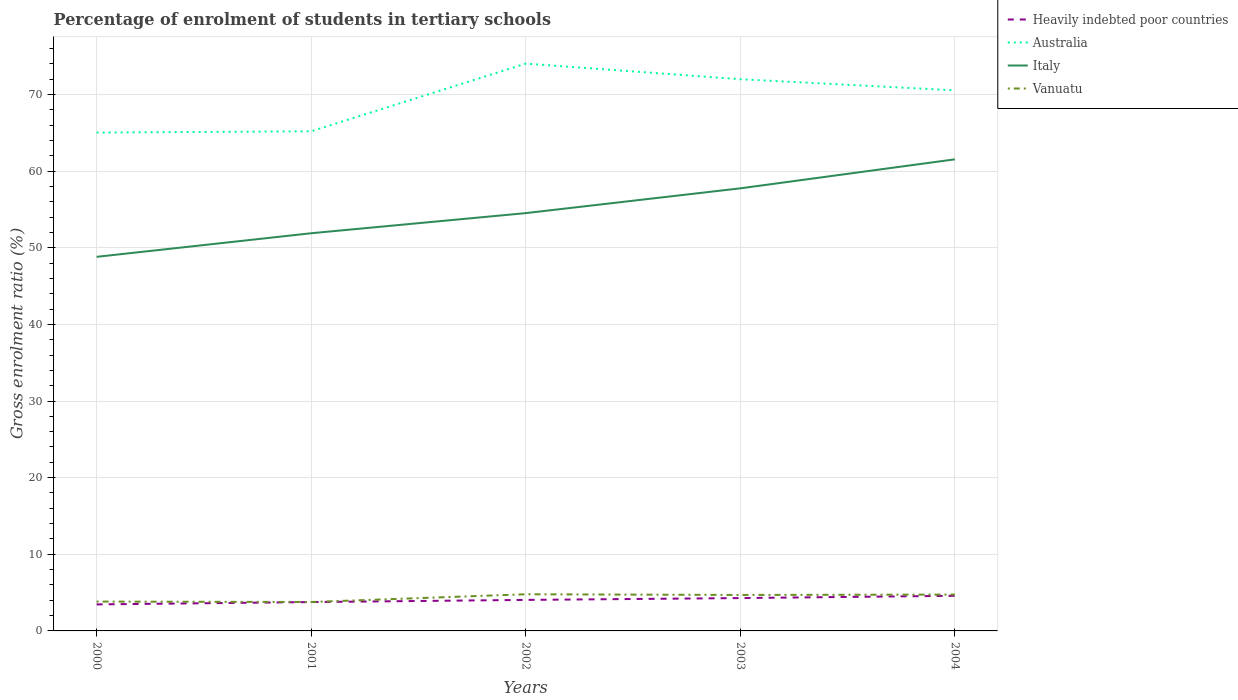Across all years, what is the maximum percentage of students enrolled in tertiary schools in Italy?
Your answer should be very brief. 48.81. In which year was the percentage of students enrolled in tertiary schools in Vanuatu maximum?
Your answer should be compact. 2001. What is the total percentage of students enrolled in tertiary schools in Italy in the graph?
Offer a terse response. -8.94. What is the difference between the highest and the second highest percentage of students enrolled in tertiary schools in Vanuatu?
Keep it short and to the point. 1.01. What is the difference between the highest and the lowest percentage of students enrolled in tertiary schools in Australia?
Ensure brevity in your answer.  3. How many lines are there?
Keep it short and to the point. 4. How many years are there in the graph?
Your answer should be compact. 5. What is the difference between two consecutive major ticks on the Y-axis?
Offer a very short reply. 10. Are the values on the major ticks of Y-axis written in scientific E-notation?
Offer a terse response. No. Does the graph contain any zero values?
Provide a short and direct response. No. How are the legend labels stacked?
Your answer should be very brief. Vertical. What is the title of the graph?
Your answer should be very brief. Percentage of enrolment of students in tertiary schools. What is the Gross enrolment ratio (%) in Heavily indebted poor countries in 2000?
Give a very brief answer. 3.46. What is the Gross enrolment ratio (%) in Australia in 2000?
Your answer should be compact. 65.03. What is the Gross enrolment ratio (%) of Italy in 2000?
Your answer should be very brief. 48.81. What is the Gross enrolment ratio (%) of Vanuatu in 2000?
Your response must be concise. 3.83. What is the Gross enrolment ratio (%) of Heavily indebted poor countries in 2001?
Your answer should be very brief. 3.76. What is the Gross enrolment ratio (%) of Australia in 2001?
Give a very brief answer. 65.19. What is the Gross enrolment ratio (%) of Italy in 2001?
Provide a short and direct response. 51.89. What is the Gross enrolment ratio (%) of Vanuatu in 2001?
Your answer should be very brief. 3.77. What is the Gross enrolment ratio (%) in Heavily indebted poor countries in 2002?
Make the answer very short. 4.05. What is the Gross enrolment ratio (%) in Australia in 2002?
Ensure brevity in your answer.  74.02. What is the Gross enrolment ratio (%) of Italy in 2002?
Offer a terse response. 54.52. What is the Gross enrolment ratio (%) of Vanuatu in 2002?
Give a very brief answer. 4.78. What is the Gross enrolment ratio (%) in Heavily indebted poor countries in 2003?
Offer a terse response. 4.29. What is the Gross enrolment ratio (%) in Australia in 2003?
Provide a succinct answer. 71.99. What is the Gross enrolment ratio (%) in Italy in 2003?
Your answer should be very brief. 57.75. What is the Gross enrolment ratio (%) of Vanuatu in 2003?
Your answer should be very brief. 4.69. What is the Gross enrolment ratio (%) of Heavily indebted poor countries in 2004?
Ensure brevity in your answer.  4.58. What is the Gross enrolment ratio (%) of Australia in 2004?
Give a very brief answer. 70.54. What is the Gross enrolment ratio (%) of Italy in 2004?
Your answer should be very brief. 61.53. What is the Gross enrolment ratio (%) in Vanuatu in 2004?
Ensure brevity in your answer.  4.74. Across all years, what is the maximum Gross enrolment ratio (%) in Heavily indebted poor countries?
Give a very brief answer. 4.58. Across all years, what is the maximum Gross enrolment ratio (%) in Australia?
Your answer should be compact. 74.02. Across all years, what is the maximum Gross enrolment ratio (%) of Italy?
Your response must be concise. 61.53. Across all years, what is the maximum Gross enrolment ratio (%) of Vanuatu?
Keep it short and to the point. 4.78. Across all years, what is the minimum Gross enrolment ratio (%) of Heavily indebted poor countries?
Make the answer very short. 3.46. Across all years, what is the minimum Gross enrolment ratio (%) in Australia?
Provide a short and direct response. 65.03. Across all years, what is the minimum Gross enrolment ratio (%) of Italy?
Your response must be concise. 48.81. Across all years, what is the minimum Gross enrolment ratio (%) in Vanuatu?
Your response must be concise. 3.77. What is the total Gross enrolment ratio (%) of Heavily indebted poor countries in the graph?
Your response must be concise. 20.14. What is the total Gross enrolment ratio (%) in Australia in the graph?
Offer a terse response. 346.76. What is the total Gross enrolment ratio (%) of Italy in the graph?
Provide a short and direct response. 274.5. What is the total Gross enrolment ratio (%) in Vanuatu in the graph?
Keep it short and to the point. 21.82. What is the difference between the Gross enrolment ratio (%) of Heavily indebted poor countries in 2000 and that in 2001?
Provide a short and direct response. -0.3. What is the difference between the Gross enrolment ratio (%) in Australia in 2000 and that in 2001?
Ensure brevity in your answer.  -0.17. What is the difference between the Gross enrolment ratio (%) of Italy in 2000 and that in 2001?
Ensure brevity in your answer.  -3.08. What is the difference between the Gross enrolment ratio (%) of Vanuatu in 2000 and that in 2001?
Provide a succinct answer. 0.06. What is the difference between the Gross enrolment ratio (%) of Heavily indebted poor countries in 2000 and that in 2002?
Provide a short and direct response. -0.59. What is the difference between the Gross enrolment ratio (%) in Australia in 2000 and that in 2002?
Your answer should be compact. -9. What is the difference between the Gross enrolment ratio (%) in Italy in 2000 and that in 2002?
Offer a very short reply. -5.7. What is the difference between the Gross enrolment ratio (%) of Vanuatu in 2000 and that in 2002?
Make the answer very short. -0.95. What is the difference between the Gross enrolment ratio (%) in Heavily indebted poor countries in 2000 and that in 2003?
Offer a very short reply. -0.83. What is the difference between the Gross enrolment ratio (%) of Australia in 2000 and that in 2003?
Make the answer very short. -6.96. What is the difference between the Gross enrolment ratio (%) in Italy in 2000 and that in 2003?
Your answer should be compact. -8.94. What is the difference between the Gross enrolment ratio (%) of Vanuatu in 2000 and that in 2003?
Your answer should be very brief. -0.86. What is the difference between the Gross enrolment ratio (%) in Heavily indebted poor countries in 2000 and that in 2004?
Give a very brief answer. -1.12. What is the difference between the Gross enrolment ratio (%) of Australia in 2000 and that in 2004?
Keep it short and to the point. -5.51. What is the difference between the Gross enrolment ratio (%) in Italy in 2000 and that in 2004?
Give a very brief answer. -12.72. What is the difference between the Gross enrolment ratio (%) in Vanuatu in 2000 and that in 2004?
Offer a very short reply. -0.91. What is the difference between the Gross enrolment ratio (%) in Heavily indebted poor countries in 2001 and that in 2002?
Ensure brevity in your answer.  -0.28. What is the difference between the Gross enrolment ratio (%) in Australia in 2001 and that in 2002?
Your answer should be very brief. -8.83. What is the difference between the Gross enrolment ratio (%) of Italy in 2001 and that in 2002?
Give a very brief answer. -2.63. What is the difference between the Gross enrolment ratio (%) of Vanuatu in 2001 and that in 2002?
Keep it short and to the point. -1.01. What is the difference between the Gross enrolment ratio (%) of Heavily indebted poor countries in 2001 and that in 2003?
Your answer should be compact. -0.52. What is the difference between the Gross enrolment ratio (%) of Australia in 2001 and that in 2003?
Your answer should be very brief. -6.8. What is the difference between the Gross enrolment ratio (%) of Italy in 2001 and that in 2003?
Offer a very short reply. -5.86. What is the difference between the Gross enrolment ratio (%) of Vanuatu in 2001 and that in 2003?
Keep it short and to the point. -0.92. What is the difference between the Gross enrolment ratio (%) in Heavily indebted poor countries in 2001 and that in 2004?
Keep it short and to the point. -0.82. What is the difference between the Gross enrolment ratio (%) of Australia in 2001 and that in 2004?
Ensure brevity in your answer.  -5.34. What is the difference between the Gross enrolment ratio (%) in Italy in 2001 and that in 2004?
Provide a succinct answer. -9.64. What is the difference between the Gross enrolment ratio (%) in Vanuatu in 2001 and that in 2004?
Offer a terse response. -0.97. What is the difference between the Gross enrolment ratio (%) in Heavily indebted poor countries in 2002 and that in 2003?
Provide a succinct answer. -0.24. What is the difference between the Gross enrolment ratio (%) in Australia in 2002 and that in 2003?
Ensure brevity in your answer.  2.04. What is the difference between the Gross enrolment ratio (%) of Italy in 2002 and that in 2003?
Make the answer very short. -3.23. What is the difference between the Gross enrolment ratio (%) of Vanuatu in 2002 and that in 2003?
Your answer should be compact. 0.09. What is the difference between the Gross enrolment ratio (%) of Heavily indebted poor countries in 2002 and that in 2004?
Your answer should be very brief. -0.54. What is the difference between the Gross enrolment ratio (%) in Australia in 2002 and that in 2004?
Your answer should be very brief. 3.49. What is the difference between the Gross enrolment ratio (%) in Italy in 2002 and that in 2004?
Offer a very short reply. -7.02. What is the difference between the Gross enrolment ratio (%) in Vanuatu in 2002 and that in 2004?
Your answer should be very brief. 0.04. What is the difference between the Gross enrolment ratio (%) of Heavily indebted poor countries in 2003 and that in 2004?
Your answer should be very brief. -0.3. What is the difference between the Gross enrolment ratio (%) of Australia in 2003 and that in 2004?
Ensure brevity in your answer.  1.45. What is the difference between the Gross enrolment ratio (%) of Italy in 2003 and that in 2004?
Keep it short and to the point. -3.78. What is the difference between the Gross enrolment ratio (%) of Vanuatu in 2003 and that in 2004?
Your answer should be very brief. -0.05. What is the difference between the Gross enrolment ratio (%) in Heavily indebted poor countries in 2000 and the Gross enrolment ratio (%) in Australia in 2001?
Offer a very short reply. -61.73. What is the difference between the Gross enrolment ratio (%) in Heavily indebted poor countries in 2000 and the Gross enrolment ratio (%) in Italy in 2001?
Your answer should be compact. -48.43. What is the difference between the Gross enrolment ratio (%) in Heavily indebted poor countries in 2000 and the Gross enrolment ratio (%) in Vanuatu in 2001?
Ensure brevity in your answer.  -0.31. What is the difference between the Gross enrolment ratio (%) of Australia in 2000 and the Gross enrolment ratio (%) of Italy in 2001?
Your answer should be very brief. 13.13. What is the difference between the Gross enrolment ratio (%) in Australia in 2000 and the Gross enrolment ratio (%) in Vanuatu in 2001?
Make the answer very short. 61.25. What is the difference between the Gross enrolment ratio (%) of Italy in 2000 and the Gross enrolment ratio (%) of Vanuatu in 2001?
Offer a terse response. 45.04. What is the difference between the Gross enrolment ratio (%) of Heavily indebted poor countries in 2000 and the Gross enrolment ratio (%) of Australia in 2002?
Make the answer very short. -70.56. What is the difference between the Gross enrolment ratio (%) in Heavily indebted poor countries in 2000 and the Gross enrolment ratio (%) in Italy in 2002?
Offer a very short reply. -51.06. What is the difference between the Gross enrolment ratio (%) of Heavily indebted poor countries in 2000 and the Gross enrolment ratio (%) of Vanuatu in 2002?
Provide a short and direct response. -1.32. What is the difference between the Gross enrolment ratio (%) in Australia in 2000 and the Gross enrolment ratio (%) in Italy in 2002?
Provide a short and direct response. 10.51. What is the difference between the Gross enrolment ratio (%) in Australia in 2000 and the Gross enrolment ratio (%) in Vanuatu in 2002?
Give a very brief answer. 60.24. What is the difference between the Gross enrolment ratio (%) in Italy in 2000 and the Gross enrolment ratio (%) in Vanuatu in 2002?
Give a very brief answer. 44.03. What is the difference between the Gross enrolment ratio (%) in Heavily indebted poor countries in 2000 and the Gross enrolment ratio (%) in Australia in 2003?
Keep it short and to the point. -68.53. What is the difference between the Gross enrolment ratio (%) in Heavily indebted poor countries in 2000 and the Gross enrolment ratio (%) in Italy in 2003?
Provide a short and direct response. -54.29. What is the difference between the Gross enrolment ratio (%) of Heavily indebted poor countries in 2000 and the Gross enrolment ratio (%) of Vanuatu in 2003?
Offer a very short reply. -1.23. What is the difference between the Gross enrolment ratio (%) in Australia in 2000 and the Gross enrolment ratio (%) in Italy in 2003?
Your response must be concise. 7.28. What is the difference between the Gross enrolment ratio (%) in Australia in 2000 and the Gross enrolment ratio (%) in Vanuatu in 2003?
Provide a short and direct response. 60.33. What is the difference between the Gross enrolment ratio (%) in Italy in 2000 and the Gross enrolment ratio (%) in Vanuatu in 2003?
Your answer should be very brief. 44.12. What is the difference between the Gross enrolment ratio (%) in Heavily indebted poor countries in 2000 and the Gross enrolment ratio (%) in Australia in 2004?
Your answer should be very brief. -67.08. What is the difference between the Gross enrolment ratio (%) in Heavily indebted poor countries in 2000 and the Gross enrolment ratio (%) in Italy in 2004?
Provide a short and direct response. -58.07. What is the difference between the Gross enrolment ratio (%) of Heavily indebted poor countries in 2000 and the Gross enrolment ratio (%) of Vanuatu in 2004?
Give a very brief answer. -1.28. What is the difference between the Gross enrolment ratio (%) in Australia in 2000 and the Gross enrolment ratio (%) in Italy in 2004?
Your response must be concise. 3.49. What is the difference between the Gross enrolment ratio (%) in Australia in 2000 and the Gross enrolment ratio (%) in Vanuatu in 2004?
Provide a succinct answer. 60.28. What is the difference between the Gross enrolment ratio (%) of Italy in 2000 and the Gross enrolment ratio (%) of Vanuatu in 2004?
Provide a short and direct response. 44.07. What is the difference between the Gross enrolment ratio (%) in Heavily indebted poor countries in 2001 and the Gross enrolment ratio (%) in Australia in 2002?
Keep it short and to the point. -70.26. What is the difference between the Gross enrolment ratio (%) of Heavily indebted poor countries in 2001 and the Gross enrolment ratio (%) of Italy in 2002?
Make the answer very short. -50.75. What is the difference between the Gross enrolment ratio (%) in Heavily indebted poor countries in 2001 and the Gross enrolment ratio (%) in Vanuatu in 2002?
Your answer should be compact. -1.02. What is the difference between the Gross enrolment ratio (%) in Australia in 2001 and the Gross enrolment ratio (%) in Italy in 2002?
Your response must be concise. 10.68. What is the difference between the Gross enrolment ratio (%) of Australia in 2001 and the Gross enrolment ratio (%) of Vanuatu in 2002?
Offer a terse response. 60.41. What is the difference between the Gross enrolment ratio (%) of Italy in 2001 and the Gross enrolment ratio (%) of Vanuatu in 2002?
Provide a short and direct response. 47.11. What is the difference between the Gross enrolment ratio (%) in Heavily indebted poor countries in 2001 and the Gross enrolment ratio (%) in Australia in 2003?
Your response must be concise. -68.22. What is the difference between the Gross enrolment ratio (%) of Heavily indebted poor countries in 2001 and the Gross enrolment ratio (%) of Italy in 2003?
Offer a very short reply. -53.99. What is the difference between the Gross enrolment ratio (%) of Heavily indebted poor countries in 2001 and the Gross enrolment ratio (%) of Vanuatu in 2003?
Make the answer very short. -0.93. What is the difference between the Gross enrolment ratio (%) in Australia in 2001 and the Gross enrolment ratio (%) in Italy in 2003?
Offer a terse response. 7.44. What is the difference between the Gross enrolment ratio (%) of Australia in 2001 and the Gross enrolment ratio (%) of Vanuatu in 2003?
Your answer should be compact. 60.5. What is the difference between the Gross enrolment ratio (%) of Italy in 2001 and the Gross enrolment ratio (%) of Vanuatu in 2003?
Make the answer very short. 47.2. What is the difference between the Gross enrolment ratio (%) of Heavily indebted poor countries in 2001 and the Gross enrolment ratio (%) of Australia in 2004?
Give a very brief answer. -66.77. What is the difference between the Gross enrolment ratio (%) of Heavily indebted poor countries in 2001 and the Gross enrolment ratio (%) of Italy in 2004?
Offer a terse response. -57.77. What is the difference between the Gross enrolment ratio (%) in Heavily indebted poor countries in 2001 and the Gross enrolment ratio (%) in Vanuatu in 2004?
Make the answer very short. -0.98. What is the difference between the Gross enrolment ratio (%) in Australia in 2001 and the Gross enrolment ratio (%) in Italy in 2004?
Make the answer very short. 3.66. What is the difference between the Gross enrolment ratio (%) in Australia in 2001 and the Gross enrolment ratio (%) in Vanuatu in 2004?
Your response must be concise. 60.45. What is the difference between the Gross enrolment ratio (%) in Italy in 2001 and the Gross enrolment ratio (%) in Vanuatu in 2004?
Your answer should be compact. 47.15. What is the difference between the Gross enrolment ratio (%) in Heavily indebted poor countries in 2002 and the Gross enrolment ratio (%) in Australia in 2003?
Your answer should be very brief. -67.94. What is the difference between the Gross enrolment ratio (%) in Heavily indebted poor countries in 2002 and the Gross enrolment ratio (%) in Italy in 2003?
Offer a very short reply. -53.7. What is the difference between the Gross enrolment ratio (%) of Heavily indebted poor countries in 2002 and the Gross enrolment ratio (%) of Vanuatu in 2003?
Ensure brevity in your answer.  -0.65. What is the difference between the Gross enrolment ratio (%) of Australia in 2002 and the Gross enrolment ratio (%) of Italy in 2003?
Provide a short and direct response. 16.27. What is the difference between the Gross enrolment ratio (%) in Australia in 2002 and the Gross enrolment ratio (%) in Vanuatu in 2003?
Ensure brevity in your answer.  69.33. What is the difference between the Gross enrolment ratio (%) in Italy in 2002 and the Gross enrolment ratio (%) in Vanuatu in 2003?
Provide a succinct answer. 49.83. What is the difference between the Gross enrolment ratio (%) in Heavily indebted poor countries in 2002 and the Gross enrolment ratio (%) in Australia in 2004?
Your answer should be very brief. -66.49. What is the difference between the Gross enrolment ratio (%) in Heavily indebted poor countries in 2002 and the Gross enrolment ratio (%) in Italy in 2004?
Make the answer very short. -57.49. What is the difference between the Gross enrolment ratio (%) in Heavily indebted poor countries in 2002 and the Gross enrolment ratio (%) in Vanuatu in 2004?
Offer a terse response. -0.7. What is the difference between the Gross enrolment ratio (%) of Australia in 2002 and the Gross enrolment ratio (%) of Italy in 2004?
Keep it short and to the point. 12.49. What is the difference between the Gross enrolment ratio (%) in Australia in 2002 and the Gross enrolment ratio (%) in Vanuatu in 2004?
Ensure brevity in your answer.  69.28. What is the difference between the Gross enrolment ratio (%) in Italy in 2002 and the Gross enrolment ratio (%) in Vanuatu in 2004?
Provide a succinct answer. 49.77. What is the difference between the Gross enrolment ratio (%) of Heavily indebted poor countries in 2003 and the Gross enrolment ratio (%) of Australia in 2004?
Make the answer very short. -66.25. What is the difference between the Gross enrolment ratio (%) in Heavily indebted poor countries in 2003 and the Gross enrolment ratio (%) in Italy in 2004?
Your answer should be compact. -57.25. What is the difference between the Gross enrolment ratio (%) of Heavily indebted poor countries in 2003 and the Gross enrolment ratio (%) of Vanuatu in 2004?
Provide a short and direct response. -0.46. What is the difference between the Gross enrolment ratio (%) of Australia in 2003 and the Gross enrolment ratio (%) of Italy in 2004?
Ensure brevity in your answer.  10.45. What is the difference between the Gross enrolment ratio (%) of Australia in 2003 and the Gross enrolment ratio (%) of Vanuatu in 2004?
Offer a very short reply. 67.24. What is the difference between the Gross enrolment ratio (%) of Italy in 2003 and the Gross enrolment ratio (%) of Vanuatu in 2004?
Give a very brief answer. 53.01. What is the average Gross enrolment ratio (%) in Heavily indebted poor countries per year?
Offer a terse response. 4.03. What is the average Gross enrolment ratio (%) in Australia per year?
Your response must be concise. 69.35. What is the average Gross enrolment ratio (%) in Italy per year?
Give a very brief answer. 54.9. What is the average Gross enrolment ratio (%) in Vanuatu per year?
Offer a very short reply. 4.36. In the year 2000, what is the difference between the Gross enrolment ratio (%) of Heavily indebted poor countries and Gross enrolment ratio (%) of Australia?
Offer a terse response. -61.57. In the year 2000, what is the difference between the Gross enrolment ratio (%) of Heavily indebted poor countries and Gross enrolment ratio (%) of Italy?
Ensure brevity in your answer.  -45.35. In the year 2000, what is the difference between the Gross enrolment ratio (%) of Heavily indebted poor countries and Gross enrolment ratio (%) of Vanuatu?
Give a very brief answer. -0.37. In the year 2000, what is the difference between the Gross enrolment ratio (%) of Australia and Gross enrolment ratio (%) of Italy?
Offer a very short reply. 16.21. In the year 2000, what is the difference between the Gross enrolment ratio (%) of Australia and Gross enrolment ratio (%) of Vanuatu?
Your answer should be compact. 61.2. In the year 2000, what is the difference between the Gross enrolment ratio (%) in Italy and Gross enrolment ratio (%) in Vanuatu?
Provide a succinct answer. 44.98. In the year 2001, what is the difference between the Gross enrolment ratio (%) in Heavily indebted poor countries and Gross enrolment ratio (%) in Australia?
Offer a terse response. -61.43. In the year 2001, what is the difference between the Gross enrolment ratio (%) in Heavily indebted poor countries and Gross enrolment ratio (%) in Italy?
Your response must be concise. -48.13. In the year 2001, what is the difference between the Gross enrolment ratio (%) of Heavily indebted poor countries and Gross enrolment ratio (%) of Vanuatu?
Keep it short and to the point. -0.01. In the year 2001, what is the difference between the Gross enrolment ratio (%) in Australia and Gross enrolment ratio (%) in Italy?
Ensure brevity in your answer.  13.3. In the year 2001, what is the difference between the Gross enrolment ratio (%) in Australia and Gross enrolment ratio (%) in Vanuatu?
Your answer should be compact. 61.42. In the year 2001, what is the difference between the Gross enrolment ratio (%) of Italy and Gross enrolment ratio (%) of Vanuatu?
Offer a terse response. 48.12. In the year 2002, what is the difference between the Gross enrolment ratio (%) of Heavily indebted poor countries and Gross enrolment ratio (%) of Australia?
Your answer should be very brief. -69.98. In the year 2002, what is the difference between the Gross enrolment ratio (%) of Heavily indebted poor countries and Gross enrolment ratio (%) of Italy?
Your answer should be very brief. -50.47. In the year 2002, what is the difference between the Gross enrolment ratio (%) of Heavily indebted poor countries and Gross enrolment ratio (%) of Vanuatu?
Ensure brevity in your answer.  -0.74. In the year 2002, what is the difference between the Gross enrolment ratio (%) of Australia and Gross enrolment ratio (%) of Italy?
Ensure brevity in your answer.  19.51. In the year 2002, what is the difference between the Gross enrolment ratio (%) in Australia and Gross enrolment ratio (%) in Vanuatu?
Provide a short and direct response. 69.24. In the year 2002, what is the difference between the Gross enrolment ratio (%) of Italy and Gross enrolment ratio (%) of Vanuatu?
Offer a terse response. 49.73. In the year 2003, what is the difference between the Gross enrolment ratio (%) of Heavily indebted poor countries and Gross enrolment ratio (%) of Australia?
Your response must be concise. -67.7. In the year 2003, what is the difference between the Gross enrolment ratio (%) of Heavily indebted poor countries and Gross enrolment ratio (%) of Italy?
Give a very brief answer. -53.46. In the year 2003, what is the difference between the Gross enrolment ratio (%) in Heavily indebted poor countries and Gross enrolment ratio (%) in Vanuatu?
Your response must be concise. -0.41. In the year 2003, what is the difference between the Gross enrolment ratio (%) in Australia and Gross enrolment ratio (%) in Italy?
Offer a terse response. 14.24. In the year 2003, what is the difference between the Gross enrolment ratio (%) in Australia and Gross enrolment ratio (%) in Vanuatu?
Provide a succinct answer. 67.3. In the year 2003, what is the difference between the Gross enrolment ratio (%) in Italy and Gross enrolment ratio (%) in Vanuatu?
Offer a terse response. 53.06. In the year 2004, what is the difference between the Gross enrolment ratio (%) of Heavily indebted poor countries and Gross enrolment ratio (%) of Australia?
Provide a succinct answer. -65.95. In the year 2004, what is the difference between the Gross enrolment ratio (%) of Heavily indebted poor countries and Gross enrolment ratio (%) of Italy?
Keep it short and to the point. -56.95. In the year 2004, what is the difference between the Gross enrolment ratio (%) in Heavily indebted poor countries and Gross enrolment ratio (%) in Vanuatu?
Your answer should be very brief. -0.16. In the year 2004, what is the difference between the Gross enrolment ratio (%) of Australia and Gross enrolment ratio (%) of Italy?
Make the answer very short. 9. In the year 2004, what is the difference between the Gross enrolment ratio (%) of Australia and Gross enrolment ratio (%) of Vanuatu?
Offer a very short reply. 65.79. In the year 2004, what is the difference between the Gross enrolment ratio (%) of Italy and Gross enrolment ratio (%) of Vanuatu?
Keep it short and to the point. 56.79. What is the ratio of the Gross enrolment ratio (%) in Heavily indebted poor countries in 2000 to that in 2001?
Provide a short and direct response. 0.92. What is the ratio of the Gross enrolment ratio (%) in Italy in 2000 to that in 2001?
Keep it short and to the point. 0.94. What is the ratio of the Gross enrolment ratio (%) in Vanuatu in 2000 to that in 2001?
Keep it short and to the point. 1.01. What is the ratio of the Gross enrolment ratio (%) of Heavily indebted poor countries in 2000 to that in 2002?
Your answer should be compact. 0.86. What is the ratio of the Gross enrolment ratio (%) in Australia in 2000 to that in 2002?
Your answer should be very brief. 0.88. What is the ratio of the Gross enrolment ratio (%) of Italy in 2000 to that in 2002?
Your answer should be compact. 0.9. What is the ratio of the Gross enrolment ratio (%) of Vanuatu in 2000 to that in 2002?
Your answer should be compact. 0.8. What is the ratio of the Gross enrolment ratio (%) of Heavily indebted poor countries in 2000 to that in 2003?
Offer a terse response. 0.81. What is the ratio of the Gross enrolment ratio (%) of Australia in 2000 to that in 2003?
Give a very brief answer. 0.9. What is the ratio of the Gross enrolment ratio (%) of Italy in 2000 to that in 2003?
Your answer should be very brief. 0.85. What is the ratio of the Gross enrolment ratio (%) in Vanuatu in 2000 to that in 2003?
Provide a succinct answer. 0.82. What is the ratio of the Gross enrolment ratio (%) of Heavily indebted poor countries in 2000 to that in 2004?
Give a very brief answer. 0.75. What is the ratio of the Gross enrolment ratio (%) of Australia in 2000 to that in 2004?
Give a very brief answer. 0.92. What is the ratio of the Gross enrolment ratio (%) of Italy in 2000 to that in 2004?
Keep it short and to the point. 0.79. What is the ratio of the Gross enrolment ratio (%) in Vanuatu in 2000 to that in 2004?
Make the answer very short. 0.81. What is the ratio of the Gross enrolment ratio (%) of Heavily indebted poor countries in 2001 to that in 2002?
Your answer should be compact. 0.93. What is the ratio of the Gross enrolment ratio (%) of Australia in 2001 to that in 2002?
Keep it short and to the point. 0.88. What is the ratio of the Gross enrolment ratio (%) of Italy in 2001 to that in 2002?
Make the answer very short. 0.95. What is the ratio of the Gross enrolment ratio (%) in Vanuatu in 2001 to that in 2002?
Provide a succinct answer. 0.79. What is the ratio of the Gross enrolment ratio (%) in Heavily indebted poor countries in 2001 to that in 2003?
Ensure brevity in your answer.  0.88. What is the ratio of the Gross enrolment ratio (%) in Australia in 2001 to that in 2003?
Give a very brief answer. 0.91. What is the ratio of the Gross enrolment ratio (%) in Italy in 2001 to that in 2003?
Ensure brevity in your answer.  0.9. What is the ratio of the Gross enrolment ratio (%) in Vanuatu in 2001 to that in 2003?
Offer a very short reply. 0.8. What is the ratio of the Gross enrolment ratio (%) of Heavily indebted poor countries in 2001 to that in 2004?
Keep it short and to the point. 0.82. What is the ratio of the Gross enrolment ratio (%) of Australia in 2001 to that in 2004?
Your response must be concise. 0.92. What is the ratio of the Gross enrolment ratio (%) in Italy in 2001 to that in 2004?
Keep it short and to the point. 0.84. What is the ratio of the Gross enrolment ratio (%) in Vanuatu in 2001 to that in 2004?
Provide a short and direct response. 0.8. What is the ratio of the Gross enrolment ratio (%) in Heavily indebted poor countries in 2002 to that in 2003?
Provide a short and direct response. 0.94. What is the ratio of the Gross enrolment ratio (%) in Australia in 2002 to that in 2003?
Make the answer very short. 1.03. What is the ratio of the Gross enrolment ratio (%) in Italy in 2002 to that in 2003?
Your answer should be compact. 0.94. What is the ratio of the Gross enrolment ratio (%) of Vanuatu in 2002 to that in 2003?
Offer a terse response. 1.02. What is the ratio of the Gross enrolment ratio (%) in Heavily indebted poor countries in 2002 to that in 2004?
Ensure brevity in your answer.  0.88. What is the ratio of the Gross enrolment ratio (%) of Australia in 2002 to that in 2004?
Provide a short and direct response. 1.05. What is the ratio of the Gross enrolment ratio (%) of Italy in 2002 to that in 2004?
Offer a very short reply. 0.89. What is the ratio of the Gross enrolment ratio (%) of Vanuatu in 2002 to that in 2004?
Offer a very short reply. 1.01. What is the ratio of the Gross enrolment ratio (%) in Heavily indebted poor countries in 2003 to that in 2004?
Provide a short and direct response. 0.93. What is the ratio of the Gross enrolment ratio (%) in Australia in 2003 to that in 2004?
Offer a terse response. 1.02. What is the ratio of the Gross enrolment ratio (%) of Italy in 2003 to that in 2004?
Your response must be concise. 0.94. What is the ratio of the Gross enrolment ratio (%) in Vanuatu in 2003 to that in 2004?
Make the answer very short. 0.99. What is the difference between the highest and the second highest Gross enrolment ratio (%) in Heavily indebted poor countries?
Offer a very short reply. 0.3. What is the difference between the highest and the second highest Gross enrolment ratio (%) in Australia?
Provide a succinct answer. 2.04. What is the difference between the highest and the second highest Gross enrolment ratio (%) of Italy?
Offer a very short reply. 3.78. What is the difference between the highest and the second highest Gross enrolment ratio (%) in Vanuatu?
Offer a very short reply. 0.04. What is the difference between the highest and the lowest Gross enrolment ratio (%) in Heavily indebted poor countries?
Make the answer very short. 1.12. What is the difference between the highest and the lowest Gross enrolment ratio (%) in Australia?
Offer a very short reply. 9. What is the difference between the highest and the lowest Gross enrolment ratio (%) of Italy?
Provide a short and direct response. 12.72. What is the difference between the highest and the lowest Gross enrolment ratio (%) in Vanuatu?
Provide a short and direct response. 1.01. 